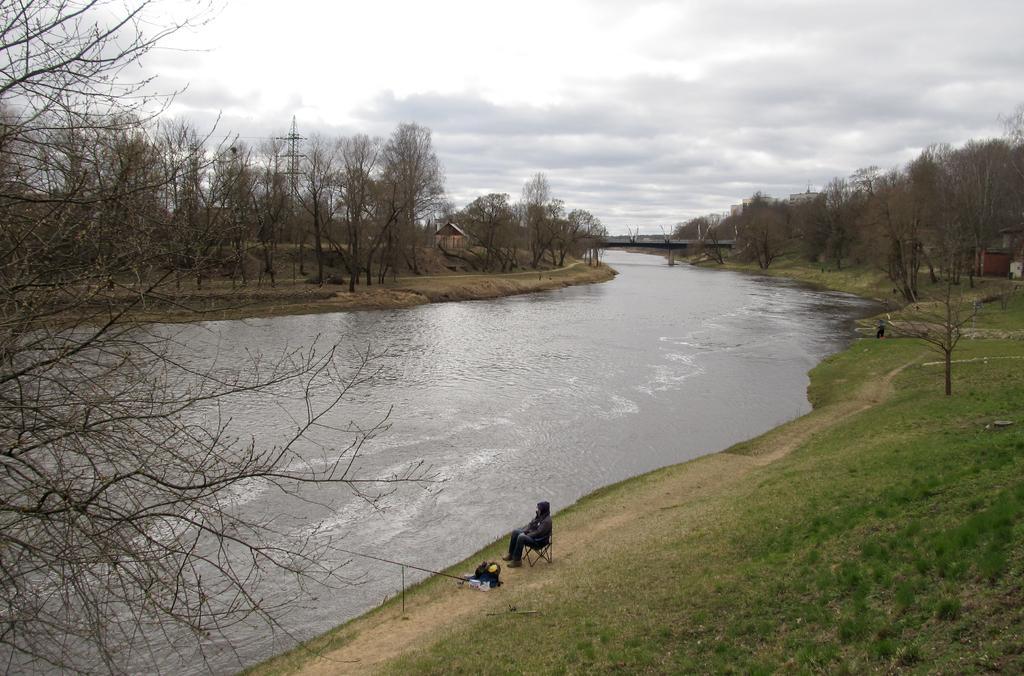Describe this image in one or two sentences. This image is clicked outside. There are trees in the middle. There is water in the middle. There is a person at the bottom. There is sky at the top. 